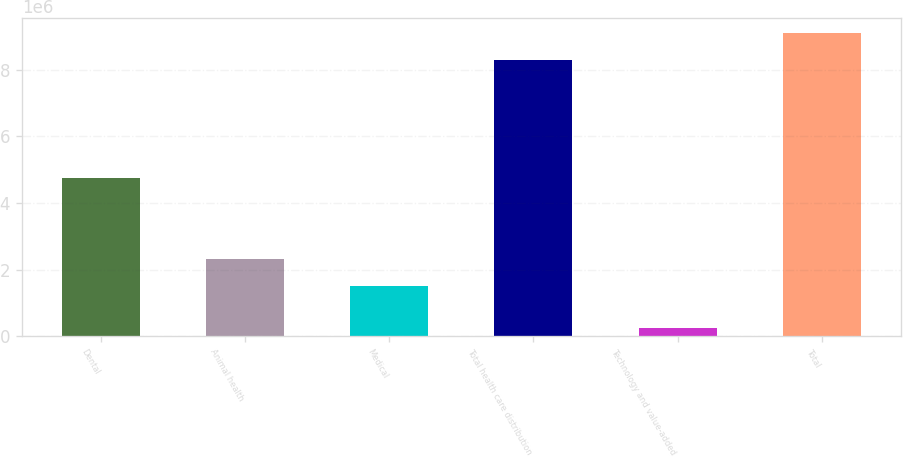<chart> <loc_0><loc_0><loc_500><loc_500><bar_chart><fcel>Dental<fcel>Animal health<fcel>Medical<fcel>Total health care distribution<fcel>Technology and value-added<fcel>Total<nl><fcel>4.7649e+06<fcel>2.33242e+06<fcel>1.50445e+06<fcel>8.27962e+06<fcel>250620<fcel>9.10758e+06<nl></chart> 